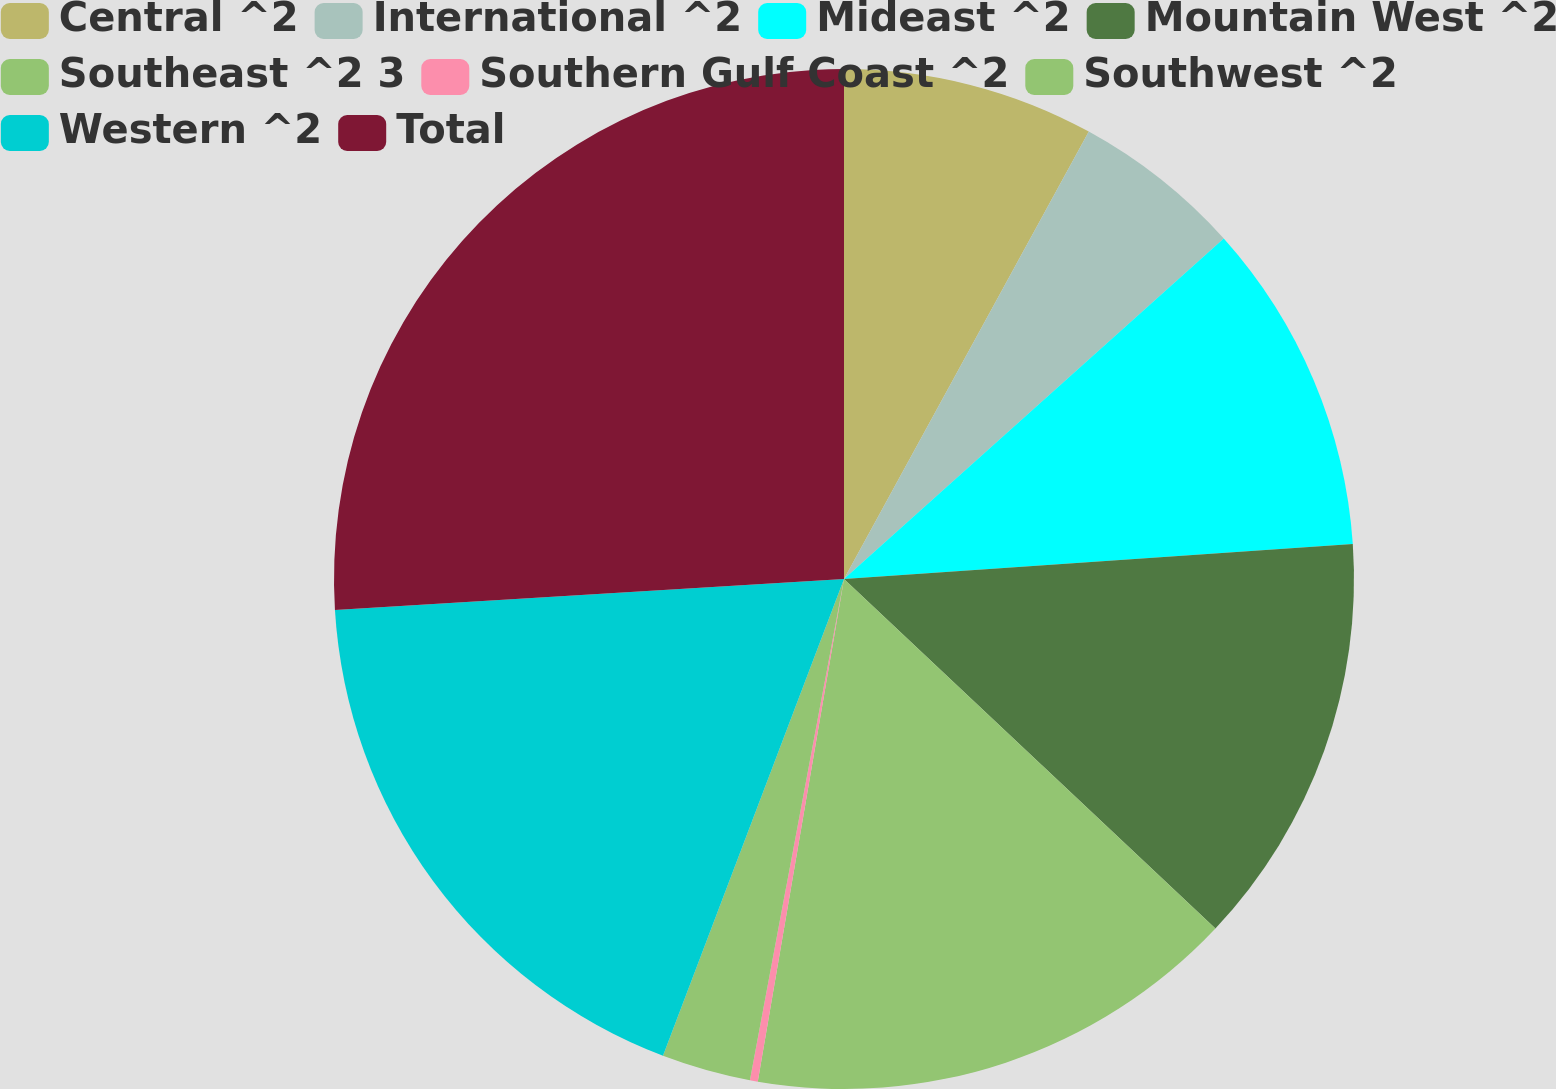Convert chart. <chart><loc_0><loc_0><loc_500><loc_500><pie_chart><fcel>Central ^2<fcel>International ^2<fcel>Mideast ^2<fcel>Mountain West ^2<fcel>Southeast ^2 3<fcel>Southern Gulf Coast ^2<fcel>Southwest ^2<fcel>Western ^2<fcel>Total<nl><fcel>7.97%<fcel>5.4%<fcel>10.54%<fcel>13.11%<fcel>15.69%<fcel>0.25%<fcel>2.82%<fcel>18.26%<fcel>25.97%<nl></chart> 